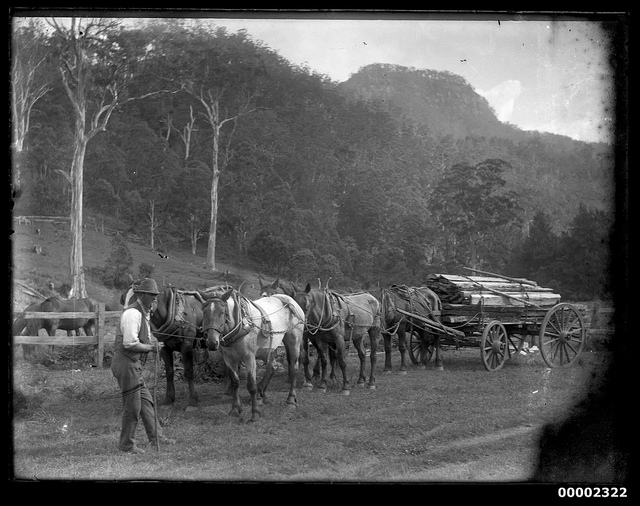What are the horses carrying, and where might they be going? The horses are pulling a load of timber, as evidenced by the logs piled on the wagon. Judging by the environment—a clearing with trees in the background—it's plausible that they're moving the timber from a logging site to a nearby mill or storage area, where it would potentially be processed or shipped elsewhere. 